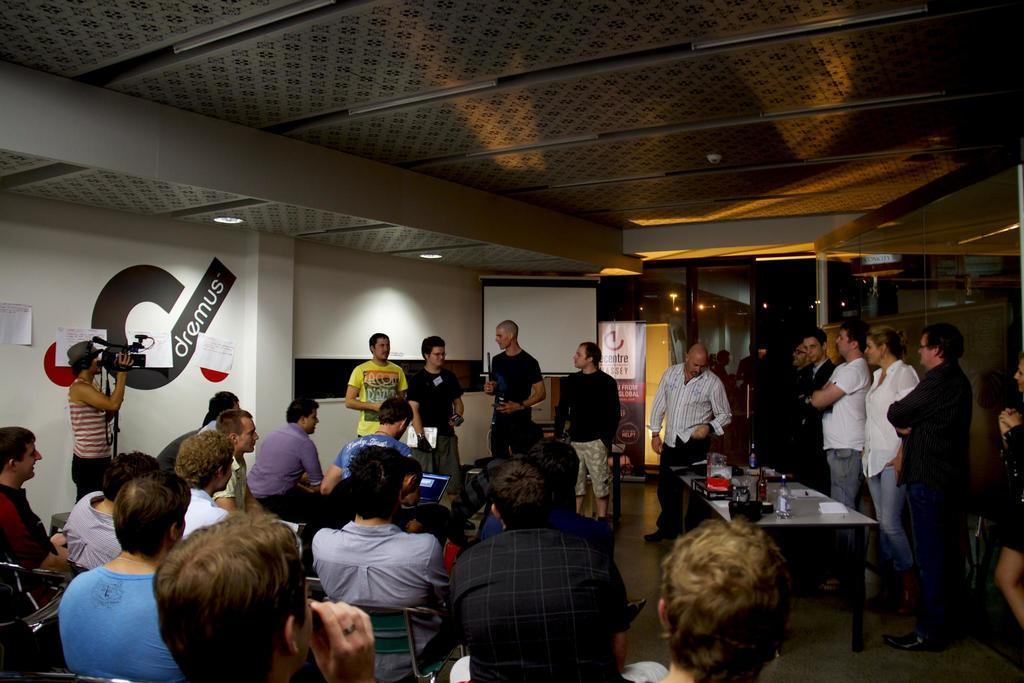In one or two sentences, can you explain what this image depicts? In this picture there are people, among them few people sitting on chairs and few people standing. We can see bottles and objects on the table, posters on the wall and banners. In the background of the image we can see lights. At the top of the image we can see lights. 